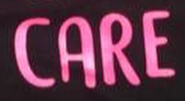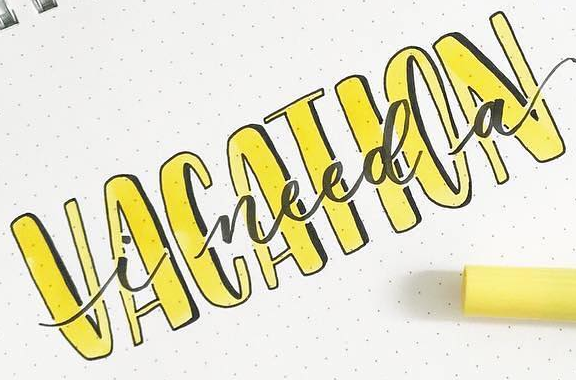Read the text content from these images in order, separated by a semicolon. CARE; VACATION 